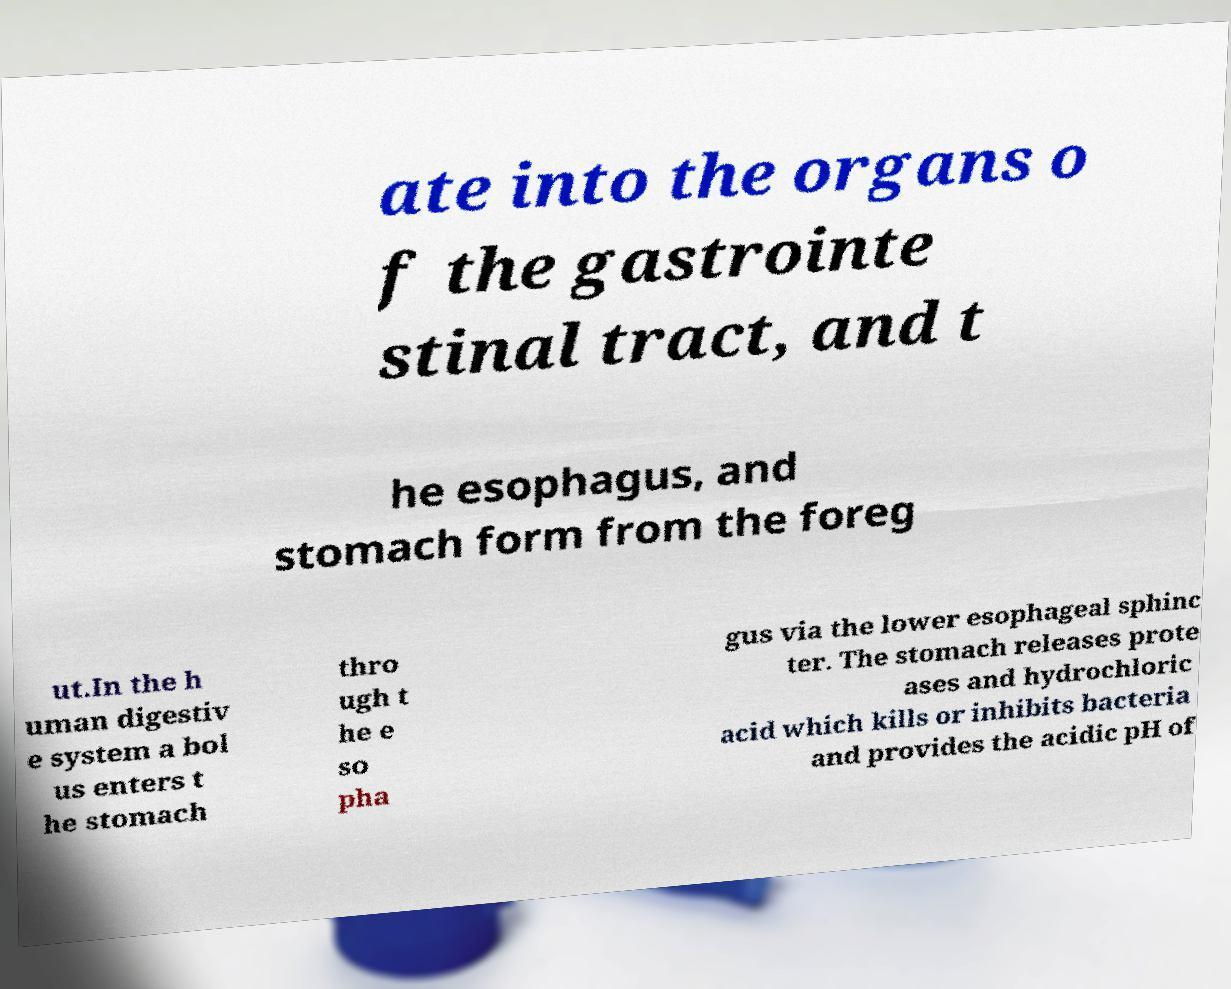Can you read and provide the text displayed in the image?This photo seems to have some interesting text. Can you extract and type it out for me? ate into the organs o f the gastrointe stinal tract, and t he esophagus, and stomach form from the foreg ut.In the h uman digestiv e system a bol us enters t he stomach thro ugh t he e so pha gus via the lower esophageal sphinc ter. The stomach releases prote ases and hydrochloric acid which kills or inhibits bacteria and provides the acidic pH of 